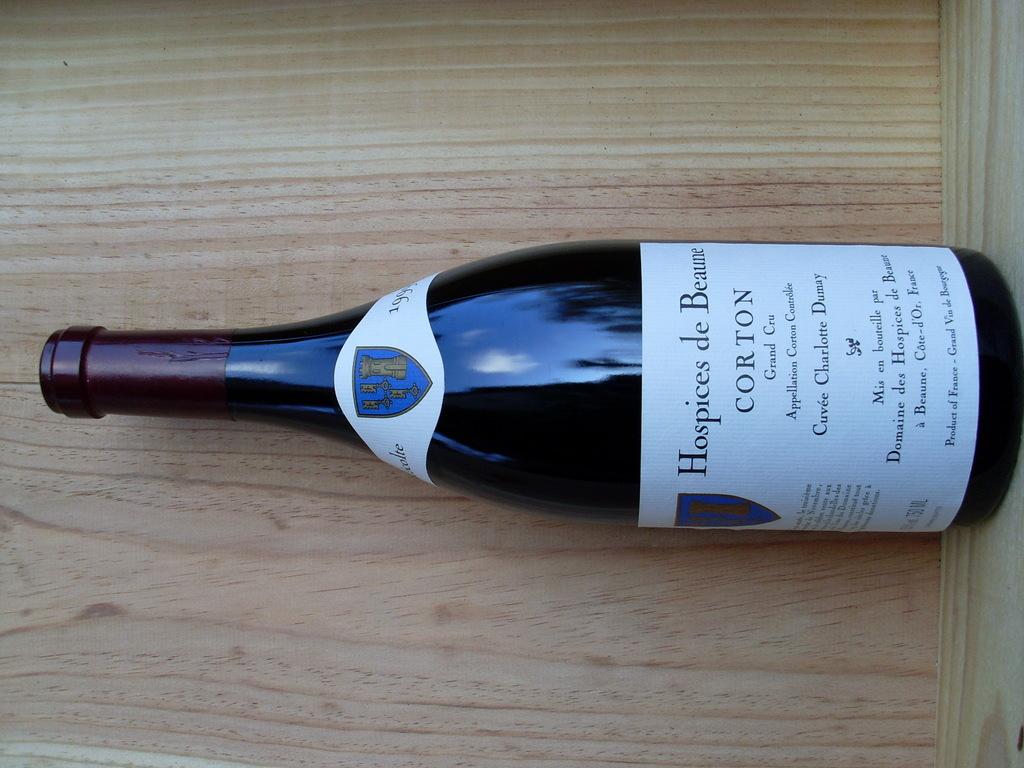What is the name of the wine?
Offer a very short reply. Corton. 